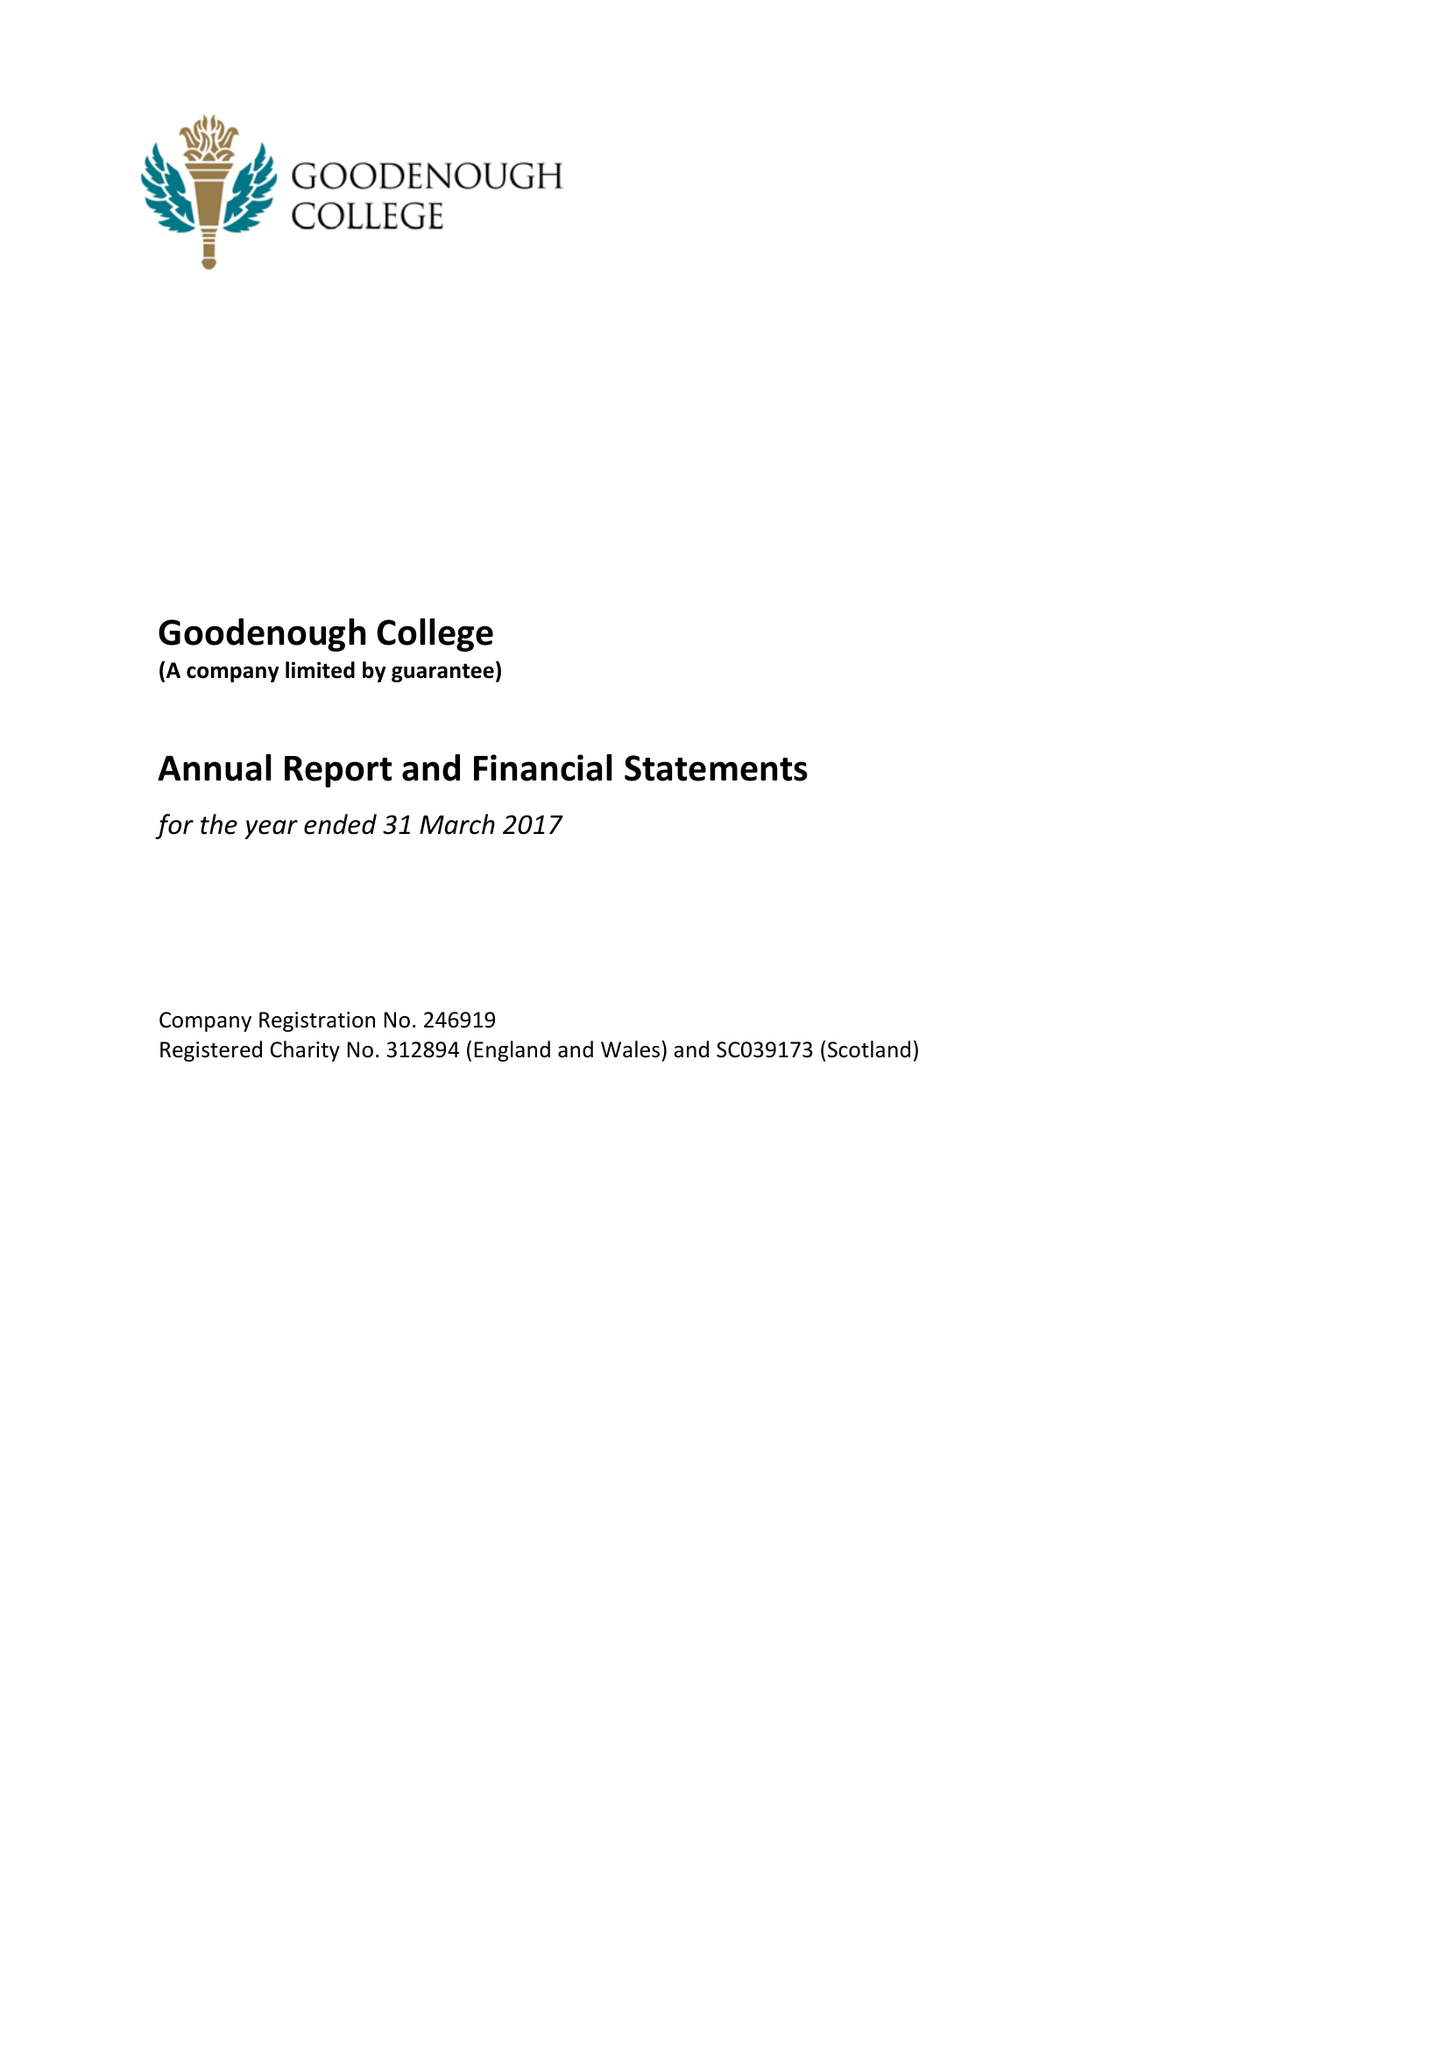What is the value for the charity_name?
Answer the question using a single word or phrase. Goodenough College 